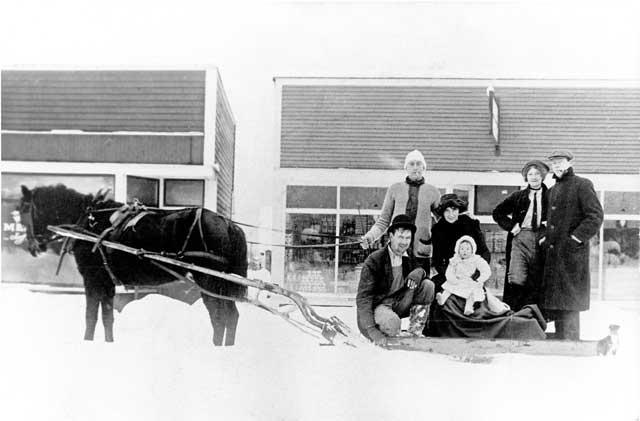How many people are posed?
Write a very short answer. 6. Is there a baby in the image?
Quick response, please. Yes. Is the photo colored?
Give a very brief answer. No. 